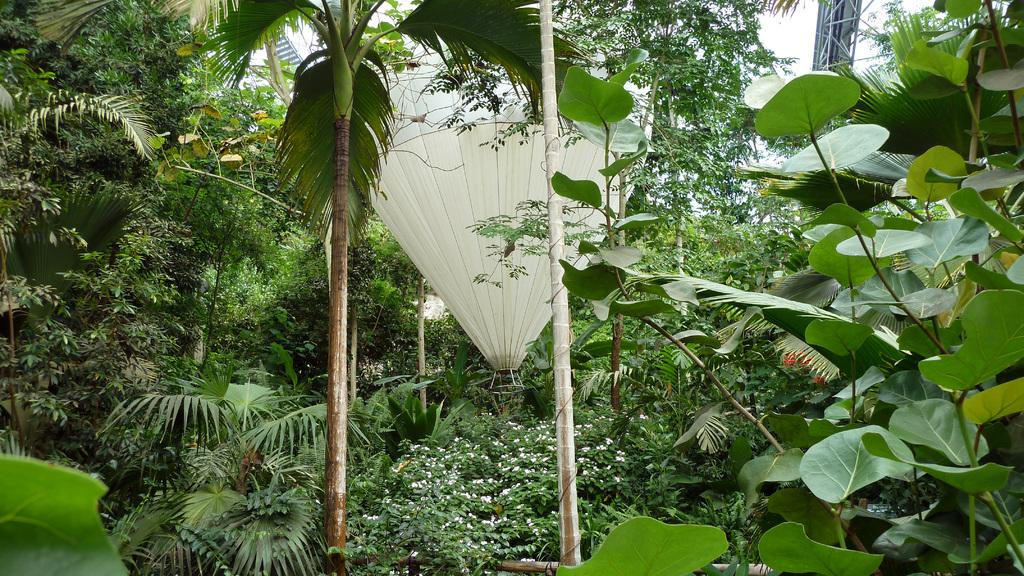What is the main subject of the image? The main subject of the image is a hot air balloon. What is unique about the appearance of the hot air balloon? The hot air balloon has plants and trees covering it. What type of support is the hot air balloon using to stay afloat in the image? The image does not show any specific support system for the hot air balloon; it is likely being lifted by the heated air inside the balloon. Can you see any cheese on or around the hot air balloon in the image? There is no cheese present in the image. 